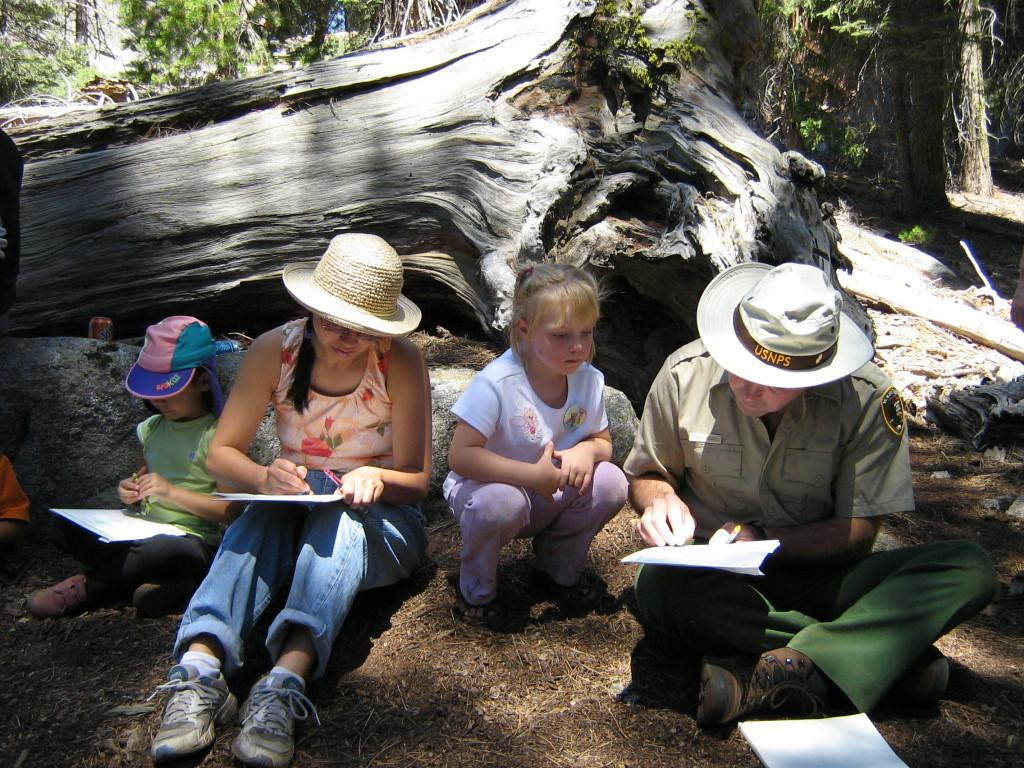What are the people in the image doing? There is a group of persons sitting on the ground. Can you describe the position of the girl in the image? There is a girl squatting in the center of the group. What is on the ground near the group? There is a paper on the ground. What can be seen in the background of the image? There are trees in the background of the image. What type of kettle is being used by the mice in the image? There are no mice or kettles present in the image. How many forks are visible in the image? There are no forks visible in the image. 